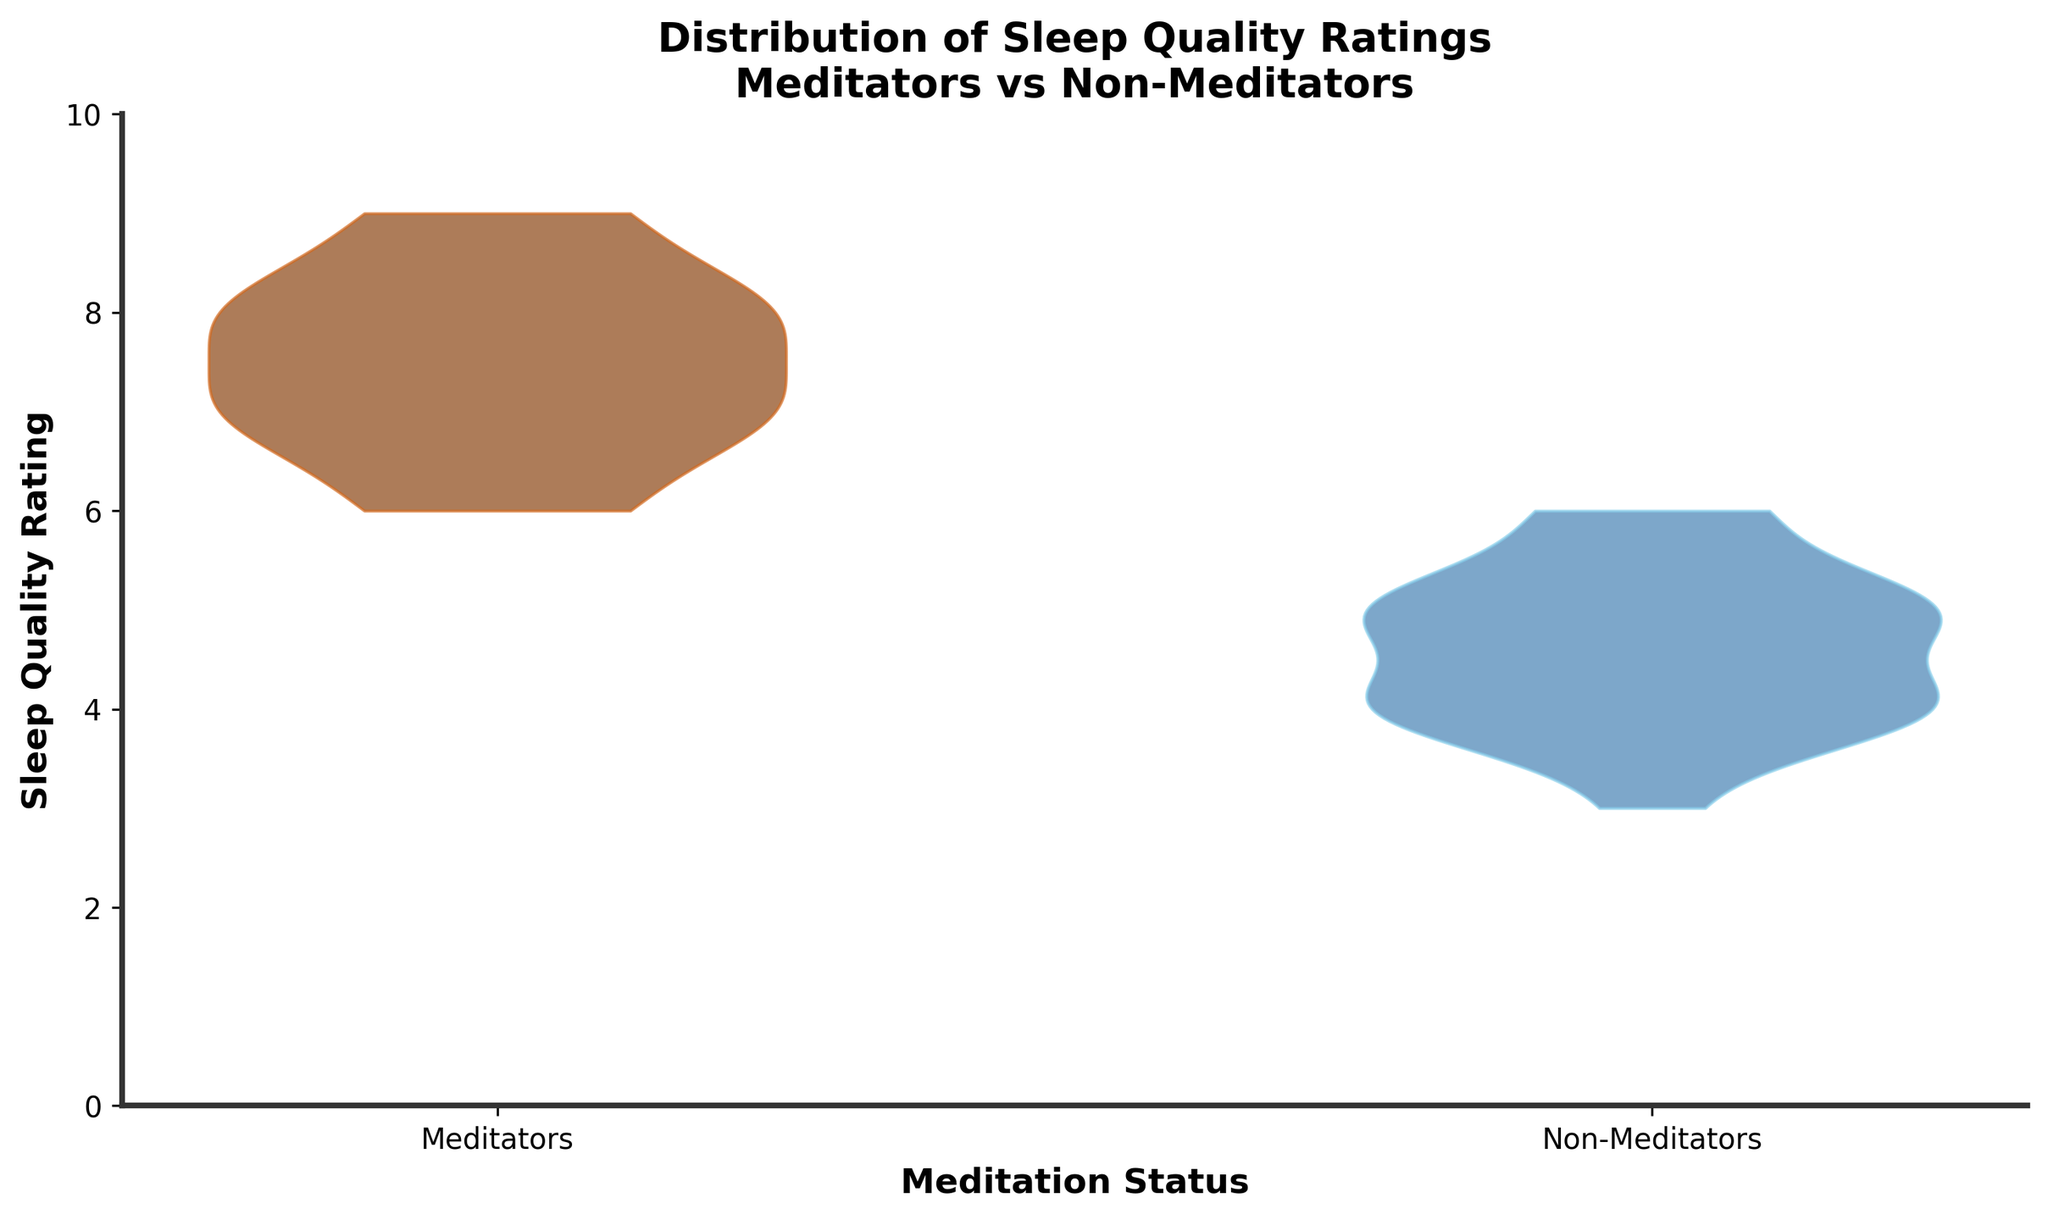what are the labels on the x-axis? The x-axis has two categories labeled: "Meditators" and "Non-Meditators." These labels represent the two groups being compared in terms of sleep quality ratings.
Answer: Meditators, Non-Meditators What does the y-axis represent? The y-axis represents the "Sleep Quality Rating," with values ranging from 0 to 10. This axis shows the possible ratings that individuals' sleep quality can receive.
Answer: Sleep Quality Rating Which group has a higher median sleep quality rating? To determine the median sleep quality rating for each group, observe the symmetric shape of each violin plot. The thicker part of the "Meditators" plot is higher on the y-axis compared to the "Non-Meditators," indicating a higher median sleep quality rating.
Answer: Meditators Describe the central tendency of sleep quality ratings for non-meditators. The central tendency for non-meditators can be observed by looking at where the violin plot is thickest. For non-meditators, the thickest part is around the 4-6 range, indicating that most sleep quality ratings for this group are between these values.
Answer: 4-6 Is there a greater spread in sleep quality ratings for meditators or non-meditators? By comparing the width of the violin plots for both groups, we see that the spread of sleep quality ratings is similar for both groups but slightly more pronounced for meditators, indicating a greater variability within that group.
Answer: Meditators What is the range of sleep quality ratings for meditators? The range of sleep quality ratings for meditators can be inferred from the violin plot, which starts around 6 and goes up to 9. Therefore, the range is from approximately 6 to 9.
Answer: 6-9 What color represents the meditators' sleep quality ratings? The meditators' sleep quality ratings are represented by a plot with a dark brown color on the plot.
Answer: Dark Brown What color represents the non-meditators' sleep quality ratings? The non-meditators' sleep quality ratings are represented by a plot with a blue color on the plot.
Answer: Blue Which group shows more consistency in their sleep quality ratings? Consistency can be inferred by the thickness and compactness of the violin plot. The "Non-Meditators" group has a tightly clustered plot, indicating more consistent (less variable) sleep quality ratings compared to the "Meditators" group.
Answer: Non-Meditators 